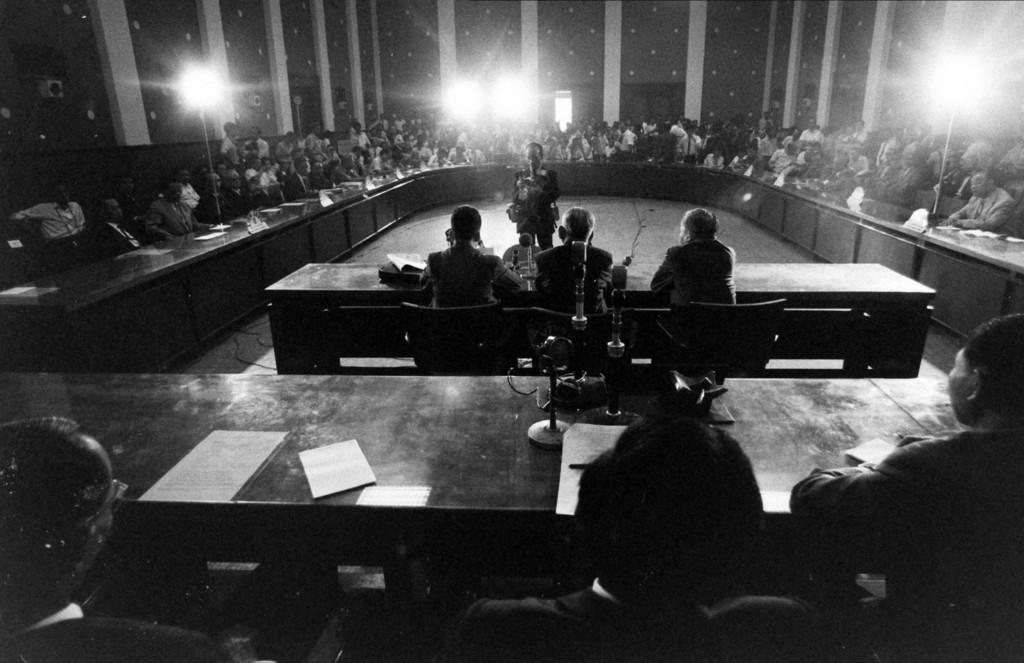What are the people in the image doing? There are people sitting and standing in the image. What type of furniture is present in the image? There are tables and chairs in the image. What is on the tables in the image? Papers and objects are present on the tables. What can be seen in the background of the image? There is a wall, pillars, and lights in the background of the image. What type of pipe can be seen running along the wall in the image? There is no pipe visible in the image; only a wall, pillars, and lights are present in the background. 